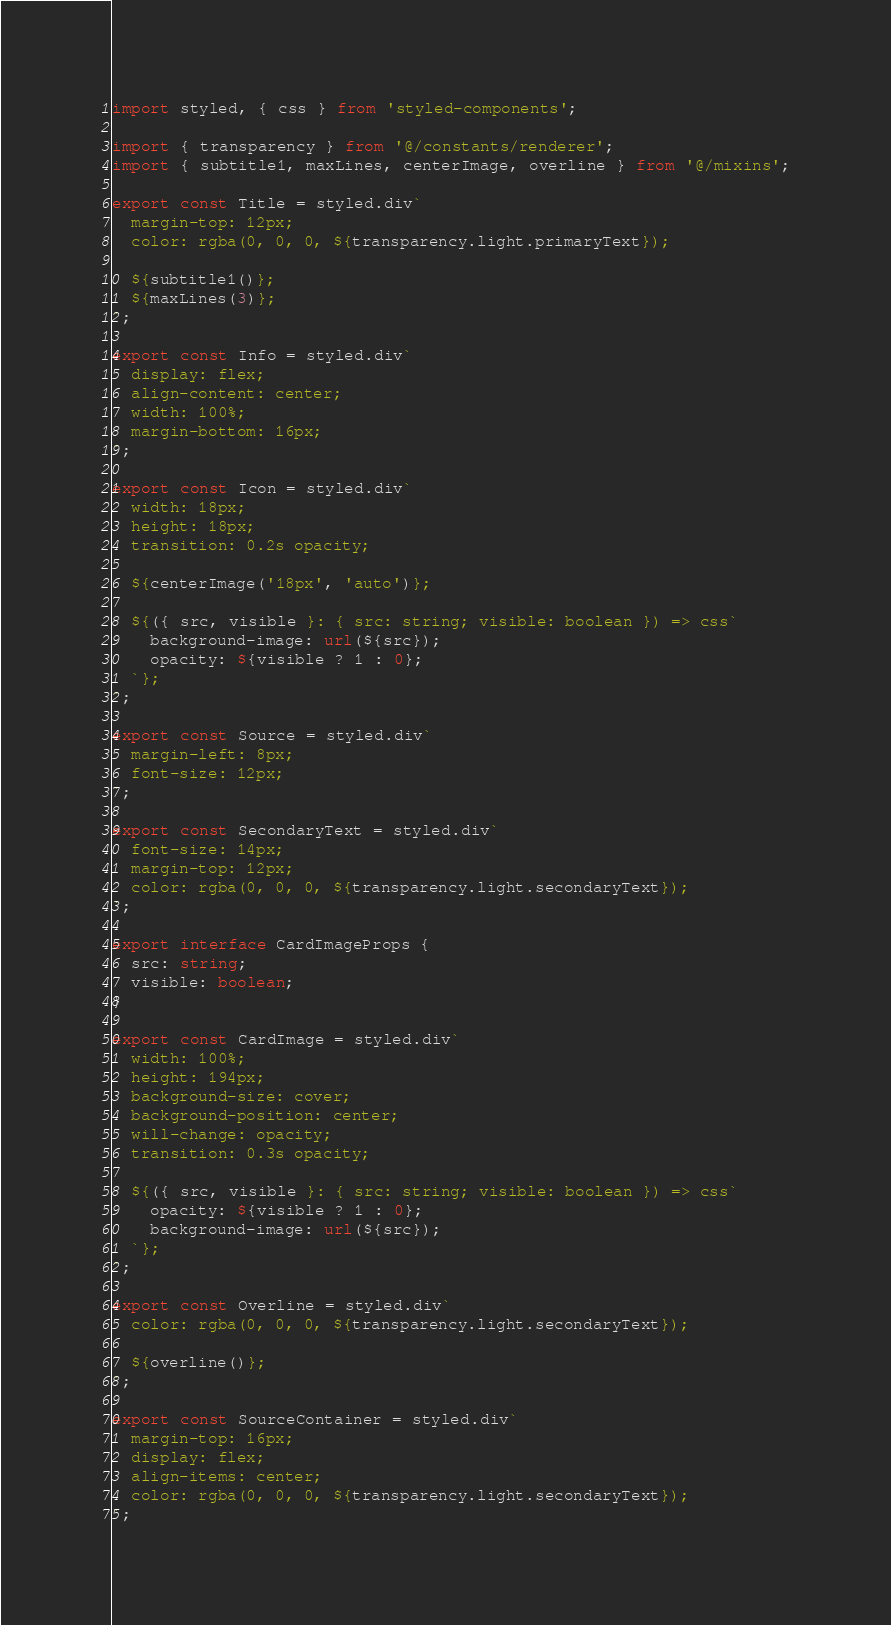Convert code to text. <code><loc_0><loc_0><loc_500><loc_500><_TypeScript_>import styled, { css } from 'styled-components';

import { transparency } from '@/constants/renderer';
import { subtitle1, maxLines, centerImage, overline } from '@/mixins';

export const Title = styled.div`
  margin-top: 12px;
  color: rgba(0, 0, 0, ${transparency.light.primaryText});

  ${subtitle1()};
  ${maxLines(3)};
`;

export const Info = styled.div`
  display: flex;
  align-content: center;
  width: 100%;
  margin-bottom: 16px;
`;

export const Icon = styled.div`
  width: 18px;
  height: 18px;
  transition: 0.2s opacity;

  ${centerImage('18px', 'auto')};

  ${({ src, visible }: { src: string; visible: boolean }) => css`
    background-image: url(${src});
    opacity: ${visible ? 1 : 0};
  `};
`;

export const Source = styled.div`
  margin-left: 8px;
  font-size: 12px;
`;

export const SecondaryText = styled.div`
  font-size: 14px;
  margin-top: 12px;
  color: rgba(0, 0, 0, ${transparency.light.secondaryText});
`;

export interface CardImageProps {
  src: string;
  visible: boolean;
}

export const CardImage = styled.div`
  width: 100%;
  height: 194px;
  background-size: cover;
  background-position: center;
  will-change: opacity;
  transition: 0.3s opacity;

  ${({ src, visible }: { src: string; visible: boolean }) => css`
    opacity: ${visible ? 1 : 0};
    background-image: url(${src});
  `};
`;

export const Overline = styled.div`
  color: rgba(0, 0, 0, ${transparency.light.secondaryText});

  ${overline()};
`;

export const SourceContainer = styled.div`
  margin-top: 16px;
  display: flex;
  align-items: center;
  color: rgba(0, 0, 0, ${transparency.light.secondaryText});
`;
</code> 